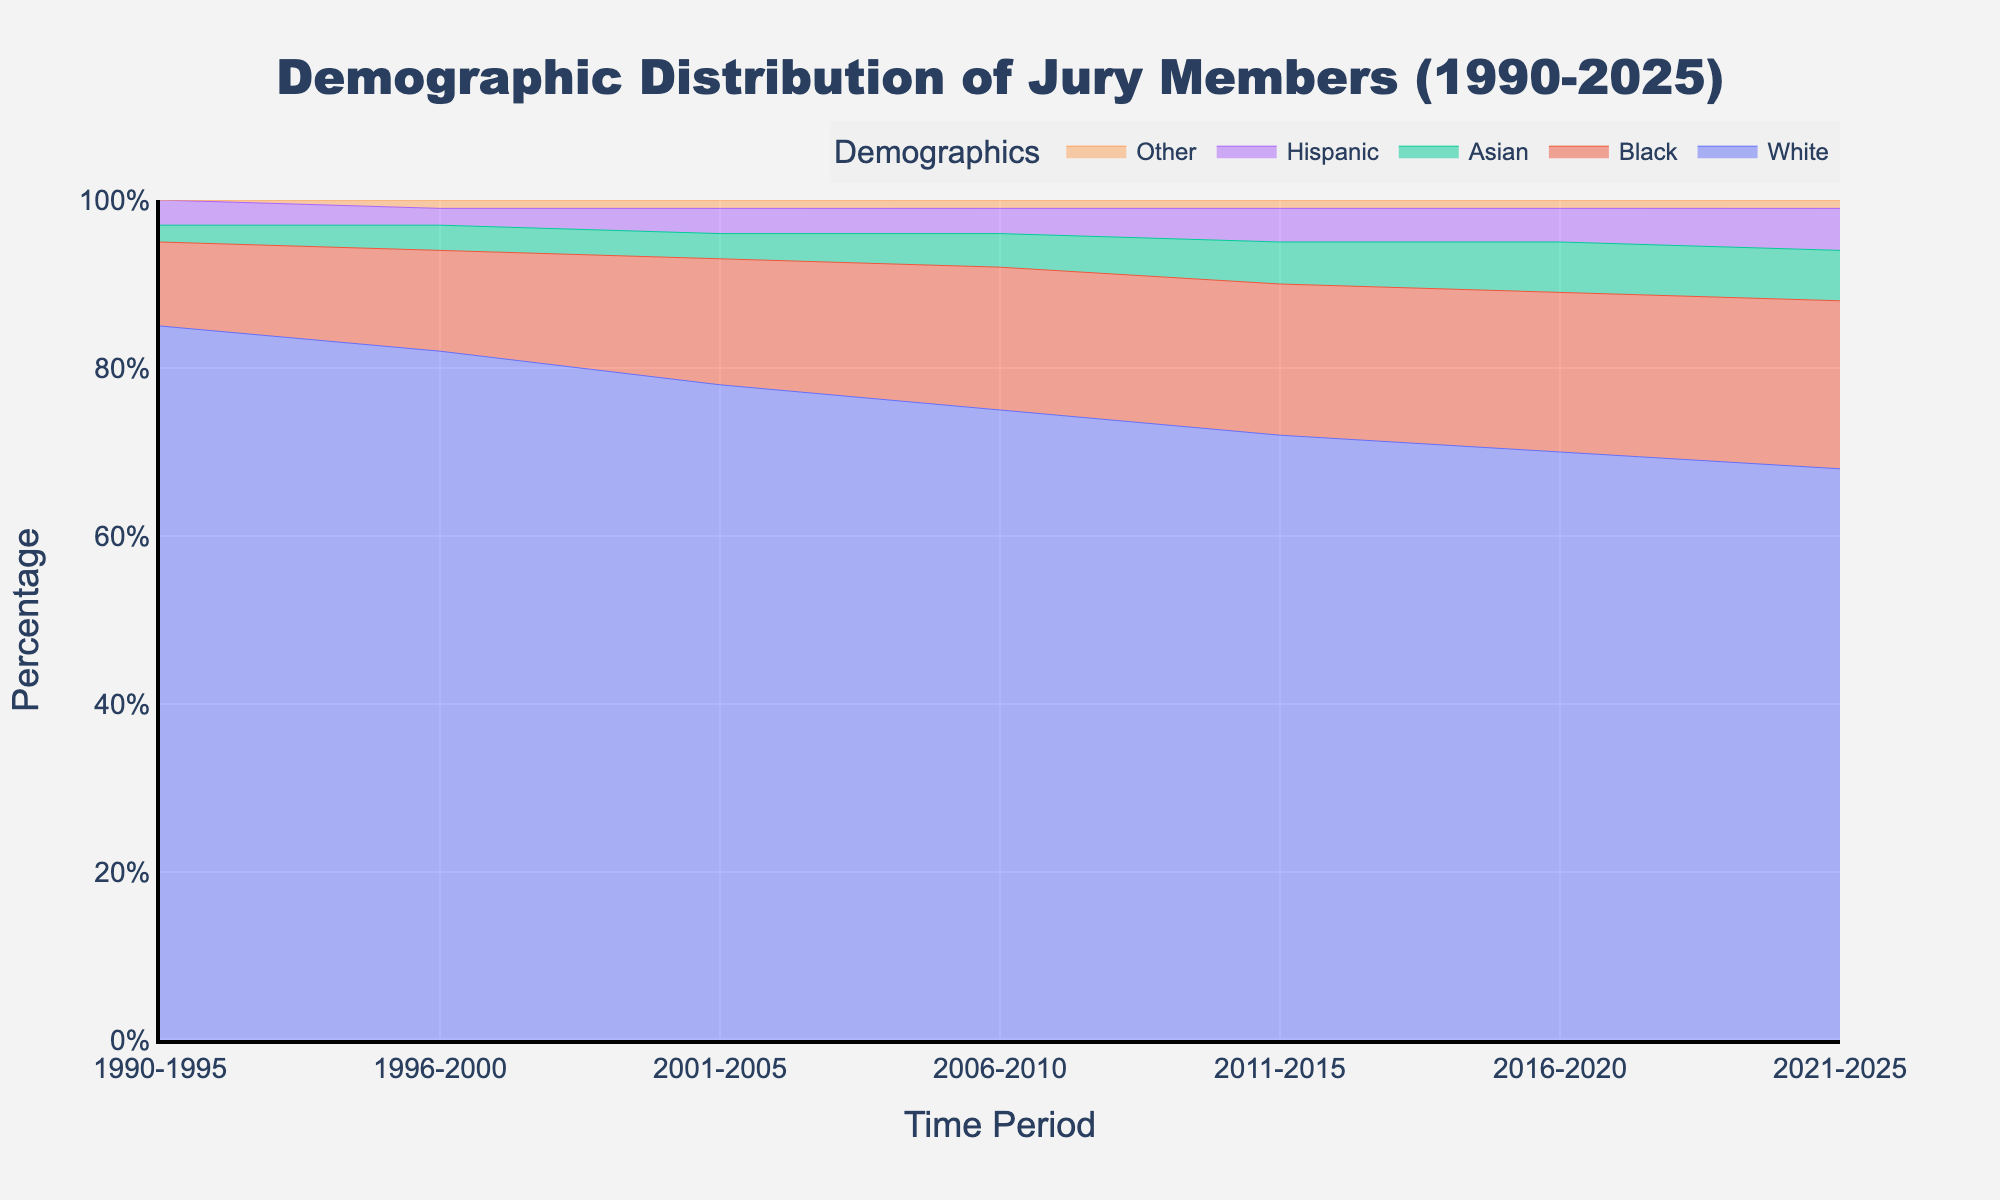What is the title of the figure? The title of the figure is usually placed at the top and is large and bold, making it easy to identify.
Answer: Demographic Distribution of Jury Members (1990-2025) What is the percentage of White jury members in the period 2011-2015? Look at the data point corresponding to the period 2011-2015 on the White demographic line.
Answer: 72% Which demographic group has shown a consistent increase from 1990-2025? Observe the trends in the lines for each demographic group to see which one has a steadily increasing slope over the periods.
Answer: Black How did the percentage of Asian jury members change from 1996-2000 to 2021-2025? Compare the y-values for Asian jury members at two different periods: 1996-2000 and 2021-2025.
Answer: It increased from 3% to 6% What is the combined percentage of Hispanic and Other jury members in the period 2001-2005? Add the percentages of Hispanic and Other jury members for the period 2001-2005.
Answer: 4% Between 2006-2010 and 2011-2015, which demographic group experienced the largest increase in percentage? Calculate the differences for each group between these periods and compare the values to determine the largest increase.
Answer: Asian In which period was the percentage of White jury members first observed to be lower than 80%? Track the periods where the White percentage dips below 80% for the first time.
Answer: 2001-2005 Which demographic group remains the smallest over all the periods? Look for the demographic group that consistently appears at the bottom of the stack in all periods.
Answer: Other What can be inferred about the trend of demographic diversity among jury members from 1990 to 2025? Examine the overall trend lines for all demographic groups to determine if they are diversifying.
Answer: Increasing diversity 